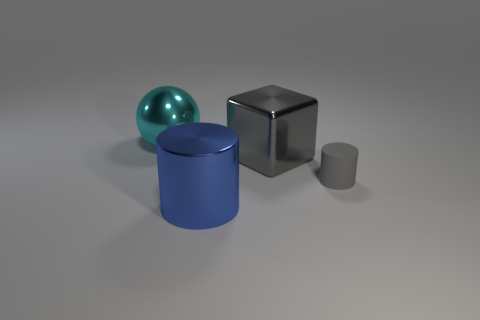Add 3 big yellow cubes. How many objects exist? 7 Subtract all spheres. How many objects are left? 3 Add 2 big balls. How many big balls exist? 3 Subtract 0 gray spheres. How many objects are left? 4 Subtract all big blue things. Subtract all tiny cyan spheres. How many objects are left? 3 Add 4 big cyan things. How many big cyan things are left? 5 